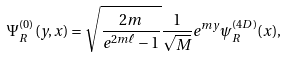<formula> <loc_0><loc_0><loc_500><loc_500>\Psi _ { R } ^ { ( 0 ) } ( y , x ) = \sqrt { \frac { 2 m } { e ^ { 2 m \ell } - 1 } } \frac { 1 } { \sqrt { M } } e ^ { m y } \psi _ { R } ^ { ( 4 D ) } ( x ) ,</formula> 